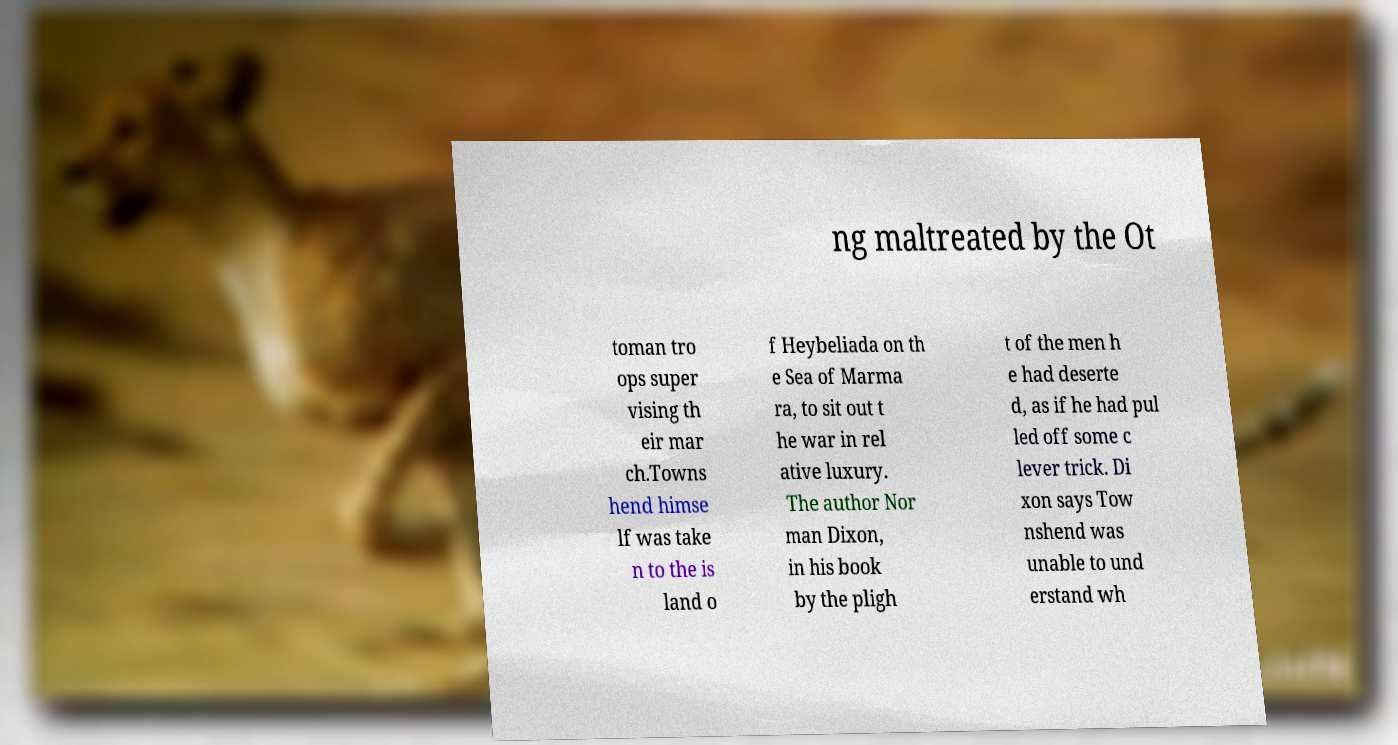What messages or text are displayed in this image? I need them in a readable, typed format. ng maltreated by the Ot toman tro ops super vising th eir mar ch.Towns hend himse lf was take n to the is land o f Heybeliada on th e Sea of Marma ra, to sit out t he war in rel ative luxury. The author Nor man Dixon, in his book by the pligh t of the men h e had deserte d, as if he had pul led off some c lever trick. Di xon says Tow nshend was unable to und erstand wh 